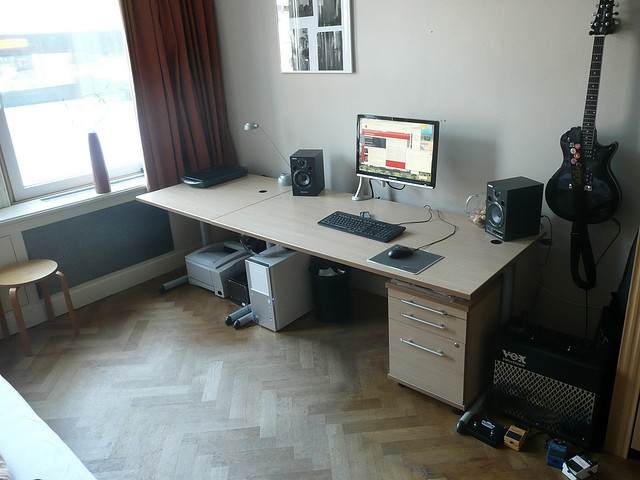Describe the objects in this image and their specific colors. I can see tv in white, ivory, darkgray, black, and gray tones, chair in white, gray, black, and darkgray tones, keyboard in white, black, purple, gray, and darkblue tones, vase in white and gray tones, and mouse in white, black, blue, purple, and darkgray tones in this image. 